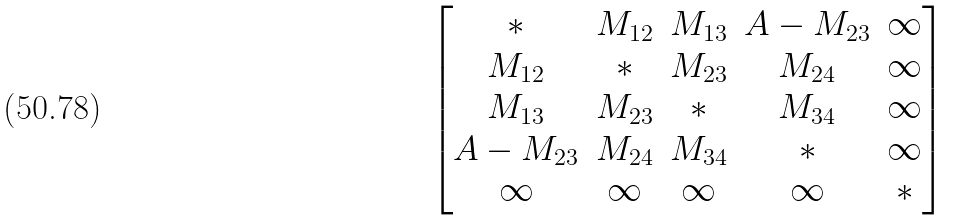<formula> <loc_0><loc_0><loc_500><loc_500>\begin{bmatrix} * & M _ { 1 2 } & M _ { 1 3 } & A - M _ { 2 3 } & \infty \\ M _ { 1 2 } & * & M _ { 2 3 } & M _ { 2 4 } & \infty \\ M _ { 1 3 } & M _ { 2 3 } & * & M _ { 3 4 } & \infty \\ A - M _ { 2 3 } & M _ { 2 4 } & M _ { 3 4 } & * & \infty \\ \infty & \infty & \infty & \infty & * \end{bmatrix}</formula> 